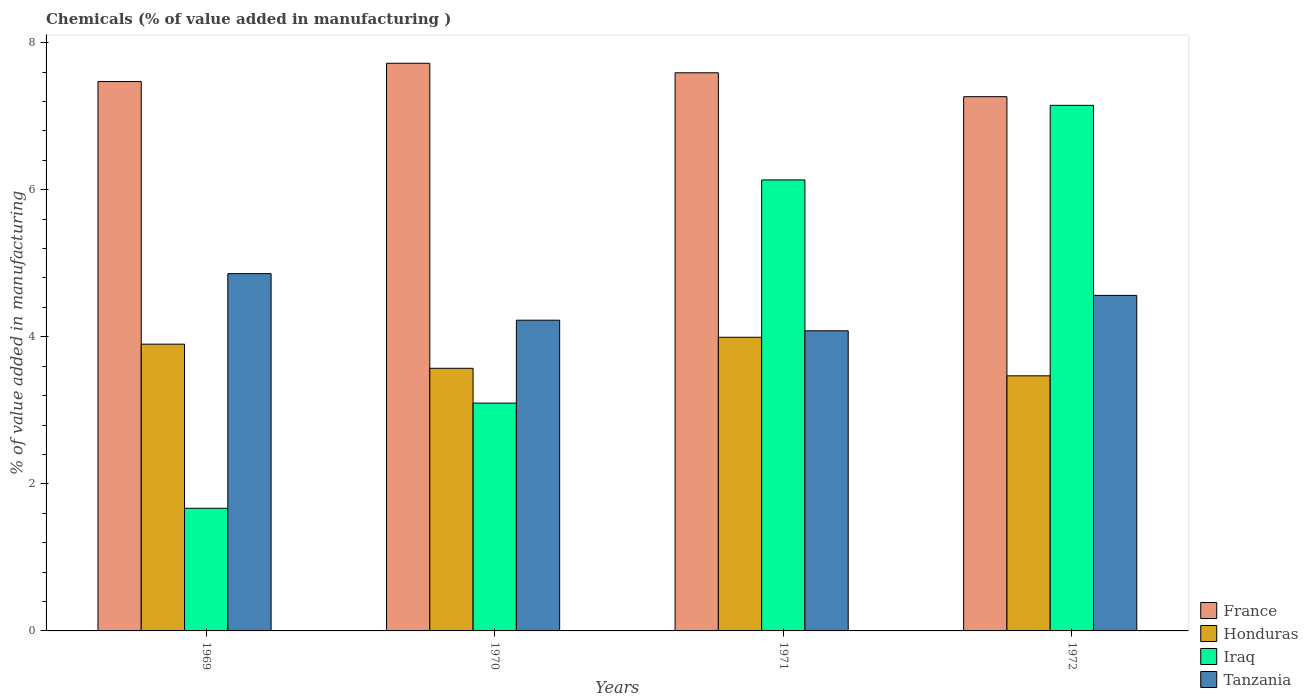How many groups of bars are there?
Your answer should be very brief. 4. Are the number of bars per tick equal to the number of legend labels?
Offer a terse response. Yes. Are the number of bars on each tick of the X-axis equal?
Provide a short and direct response. Yes. In how many cases, is the number of bars for a given year not equal to the number of legend labels?
Ensure brevity in your answer.  0. What is the value added in manufacturing chemicals in Iraq in 1969?
Provide a short and direct response. 1.67. Across all years, what is the maximum value added in manufacturing chemicals in France?
Your response must be concise. 7.72. Across all years, what is the minimum value added in manufacturing chemicals in France?
Your answer should be very brief. 7.26. In which year was the value added in manufacturing chemicals in Iraq minimum?
Provide a succinct answer. 1969. What is the total value added in manufacturing chemicals in Iraq in the graph?
Ensure brevity in your answer.  18.04. What is the difference between the value added in manufacturing chemicals in Honduras in 1969 and that in 1970?
Ensure brevity in your answer.  0.33. What is the difference between the value added in manufacturing chemicals in Honduras in 1970 and the value added in manufacturing chemicals in Tanzania in 1971?
Your answer should be compact. -0.51. What is the average value added in manufacturing chemicals in Honduras per year?
Make the answer very short. 3.73. In the year 1969, what is the difference between the value added in manufacturing chemicals in Honduras and value added in manufacturing chemicals in Tanzania?
Give a very brief answer. -0.96. In how many years, is the value added in manufacturing chemicals in France greater than 3.2 %?
Provide a succinct answer. 4. What is the ratio of the value added in manufacturing chemicals in Tanzania in 1971 to that in 1972?
Your response must be concise. 0.89. Is the value added in manufacturing chemicals in Tanzania in 1970 less than that in 1972?
Ensure brevity in your answer.  Yes. What is the difference between the highest and the second highest value added in manufacturing chemicals in Tanzania?
Provide a succinct answer. 0.3. What is the difference between the highest and the lowest value added in manufacturing chemicals in Iraq?
Provide a short and direct response. 5.48. Is it the case that in every year, the sum of the value added in manufacturing chemicals in Iraq and value added in manufacturing chemicals in France is greater than the sum of value added in manufacturing chemicals in Tanzania and value added in manufacturing chemicals in Honduras?
Give a very brief answer. No. What does the 2nd bar from the left in 1971 represents?
Your response must be concise. Honduras. What does the 1st bar from the right in 1969 represents?
Offer a very short reply. Tanzania. Is it the case that in every year, the sum of the value added in manufacturing chemicals in France and value added in manufacturing chemicals in Iraq is greater than the value added in manufacturing chemicals in Tanzania?
Your answer should be very brief. Yes. Are all the bars in the graph horizontal?
Make the answer very short. No. Are the values on the major ticks of Y-axis written in scientific E-notation?
Your answer should be compact. No. Does the graph contain grids?
Provide a succinct answer. No. Where does the legend appear in the graph?
Your answer should be very brief. Bottom right. How are the legend labels stacked?
Provide a short and direct response. Vertical. What is the title of the graph?
Offer a terse response. Chemicals (% of value added in manufacturing ). What is the label or title of the X-axis?
Your answer should be very brief. Years. What is the label or title of the Y-axis?
Make the answer very short. % of value added in manufacturing. What is the % of value added in manufacturing of France in 1969?
Your answer should be compact. 7.47. What is the % of value added in manufacturing of Honduras in 1969?
Your answer should be compact. 3.9. What is the % of value added in manufacturing in Iraq in 1969?
Your answer should be compact. 1.67. What is the % of value added in manufacturing of Tanzania in 1969?
Your answer should be compact. 4.86. What is the % of value added in manufacturing of France in 1970?
Make the answer very short. 7.72. What is the % of value added in manufacturing of Honduras in 1970?
Offer a very short reply. 3.57. What is the % of value added in manufacturing in Iraq in 1970?
Your answer should be very brief. 3.1. What is the % of value added in manufacturing in Tanzania in 1970?
Keep it short and to the point. 4.23. What is the % of value added in manufacturing of France in 1971?
Keep it short and to the point. 7.59. What is the % of value added in manufacturing in Honduras in 1971?
Offer a terse response. 3.99. What is the % of value added in manufacturing of Iraq in 1971?
Your answer should be compact. 6.13. What is the % of value added in manufacturing of Tanzania in 1971?
Give a very brief answer. 4.08. What is the % of value added in manufacturing of France in 1972?
Offer a terse response. 7.26. What is the % of value added in manufacturing of Honduras in 1972?
Your answer should be compact. 3.47. What is the % of value added in manufacturing of Iraq in 1972?
Your answer should be very brief. 7.15. What is the % of value added in manufacturing in Tanzania in 1972?
Offer a very short reply. 4.56. Across all years, what is the maximum % of value added in manufacturing of France?
Your answer should be compact. 7.72. Across all years, what is the maximum % of value added in manufacturing of Honduras?
Provide a short and direct response. 3.99. Across all years, what is the maximum % of value added in manufacturing of Iraq?
Offer a very short reply. 7.15. Across all years, what is the maximum % of value added in manufacturing in Tanzania?
Provide a short and direct response. 4.86. Across all years, what is the minimum % of value added in manufacturing of France?
Your answer should be compact. 7.26. Across all years, what is the minimum % of value added in manufacturing in Honduras?
Ensure brevity in your answer.  3.47. Across all years, what is the minimum % of value added in manufacturing of Iraq?
Provide a short and direct response. 1.67. Across all years, what is the minimum % of value added in manufacturing of Tanzania?
Offer a terse response. 4.08. What is the total % of value added in manufacturing of France in the graph?
Provide a short and direct response. 30.04. What is the total % of value added in manufacturing in Honduras in the graph?
Your answer should be very brief. 14.93. What is the total % of value added in manufacturing in Iraq in the graph?
Offer a very short reply. 18.04. What is the total % of value added in manufacturing in Tanzania in the graph?
Offer a terse response. 17.73. What is the difference between the % of value added in manufacturing of France in 1969 and that in 1970?
Make the answer very short. -0.25. What is the difference between the % of value added in manufacturing in Honduras in 1969 and that in 1970?
Your response must be concise. 0.33. What is the difference between the % of value added in manufacturing of Iraq in 1969 and that in 1970?
Your response must be concise. -1.43. What is the difference between the % of value added in manufacturing in Tanzania in 1969 and that in 1970?
Your response must be concise. 0.63. What is the difference between the % of value added in manufacturing of France in 1969 and that in 1971?
Give a very brief answer. -0.12. What is the difference between the % of value added in manufacturing of Honduras in 1969 and that in 1971?
Keep it short and to the point. -0.09. What is the difference between the % of value added in manufacturing in Iraq in 1969 and that in 1971?
Ensure brevity in your answer.  -4.46. What is the difference between the % of value added in manufacturing of Tanzania in 1969 and that in 1971?
Make the answer very short. 0.78. What is the difference between the % of value added in manufacturing in France in 1969 and that in 1972?
Ensure brevity in your answer.  0.21. What is the difference between the % of value added in manufacturing of Honduras in 1969 and that in 1972?
Your response must be concise. 0.43. What is the difference between the % of value added in manufacturing in Iraq in 1969 and that in 1972?
Keep it short and to the point. -5.48. What is the difference between the % of value added in manufacturing of Tanzania in 1969 and that in 1972?
Make the answer very short. 0.3. What is the difference between the % of value added in manufacturing of France in 1970 and that in 1971?
Offer a terse response. 0.13. What is the difference between the % of value added in manufacturing in Honduras in 1970 and that in 1971?
Ensure brevity in your answer.  -0.42. What is the difference between the % of value added in manufacturing of Iraq in 1970 and that in 1971?
Provide a succinct answer. -3.03. What is the difference between the % of value added in manufacturing in Tanzania in 1970 and that in 1971?
Provide a succinct answer. 0.14. What is the difference between the % of value added in manufacturing of France in 1970 and that in 1972?
Ensure brevity in your answer.  0.45. What is the difference between the % of value added in manufacturing of Honduras in 1970 and that in 1972?
Your answer should be very brief. 0.1. What is the difference between the % of value added in manufacturing in Iraq in 1970 and that in 1972?
Your response must be concise. -4.05. What is the difference between the % of value added in manufacturing of Tanzania in 1970 and that in 1972?
Make the answer very short. -0.34. What is the difference between the % of value added in manufacturing of France in 1971 and that in 1972?
Give a very brief answer. 0.32. What is the difference between the % of value added in manufacturing in Honduras in 1971 and that in 1972?
Offer a very short reply. 0.52. What is the difference between the % of value added in manufacturing in Iraq in 1971 and that in 1972?
Give a very brief answer. -1.01. What is the difference between the % of value added in manufacturing in Tanzania in 1971 and that in 1972?
Offer a terse response. -0.48. What is the difference between the % of value added in manufacturing in France in 1969 and the % of value added in manufacturing in Honduras in 1970?
Your answer should be very brief. 3.9. What is the difference between the % of value added in manufacturing in France in 1969 and the % of value added in manufacturing in Iraq in 1970?
Ensure brevity in your answer.  4.37. What is the difference between the % of value added in manufacturing in France in 1969 and the % of value added in manufacturing in Tanzania in 1970?
Keep it short and to the point. 3.25. What is the difference between the % of value added in manufacturing in Honduras in 1969 and the % of value added in manufacturing in Iraq in 1970?
Your answer should be compact. 0.8. What is the difference between the % of value added in manufacturing in Honduras in 1969 and the % of value added in manufacturing in Tanzania in 1970?
Make the answer very short. -0.33. What is the difference between the % of value added in manufacturing in Iraq in 1969 and the % of value added in manufacturing in Tanzania in 1970?
Offer a terse response. -2.56. What is the difference between the % of value added in manufacturing of France in 1969 and the % of value added in manufacturing of Honduras in 1971?
Make the answer very short. 3.48. What is the difference between the % of value added in manufacturing in France in 1969 and the % of value added in manufacturing in Iraq in 1971?
Make the answer very short. 1.34. What is the difference between the % of value added in manufacturing in France in 1969 and the % of value added in manufacturing in Tanzania in 1971?
Offer a very short reply. 3.39. What is the difference between the % of value added in manufacturing of Honduras in 1969 and the % of value added in manufacturing of Iraq in 1971?
Offer a terse response. -2.23. What is the difference between the % of value added in manufacturing in Honduras in 1969 and the % of value added in manufacturing in Tanzania in 1971?
Provide a short and direct response. -0.18. What is the difference between the % of value added in manufacturing in Iraq in 1969 and the % of value added in manufacturing in Tanzania in 1971?
Your answer should be very brief. -2.41. What is the difference between the % of value added in manufacturing in France in 1969 and the % of value added in manufacturing in Honduras in 1972?
Your response must be concise. 4. What is the difference between the % of value added in manufacturing in France in 1969 and the % of value added in manufacturing in Iraq in 1972?
Ensure brevity in your answer.  0.32. What is the difference between the % of value added in manufacturing of France in 1969 and the % of value added in manufacturing of Tanzania in 1972?
Keep it short and to the point. 2.91. What is the difference between the % of value added in manufacturing in Honduras in 1969 and the % of value added in manufacturing in Iraq in 1972?
Give a very brief answer. -3.25. What is the difference between the % of value added in manufacturing in Honduras in 1969 and the % of value added in manufacturing in Tanzania in 1972?
Offer a very short reply. -0.66. What is the difference between the % of value added in manufacturing in Iraq in 1969 and the % of value added in manufacturing in Tanzania in 1972?
Ensure brevity in your answer.  -2.89. What is the difference between the % of value added in manufacturing of France in 1970 and the % of value added in manufacturing of Honduras in 1971?
Offer a terse response. 3.73. What is the difference between the % of value added in manufacturing of France in 1970 and the % of value added in manufacturing of Iraq in 1971?
Your answer should be compact. 1.59. What is the difference between the % of value added in manufacturing of France in 1970 and the % of value added in manufacturing of Tanzania in 1971?
Offer a very short reply. 3.64. What is the difference between the % of value added in manufacturing in Honduras in 1970 and the % of value added in manufacturing in Iraq in 1971?
Provide a succinct answer. -2.56. What is the difference between the % of value added in manufacturing in Honduras in 1970 and the % of value added in manufacturing in Tanzania in 1971?
Offer a very short reply. -0.51. What is the difference between the % of value added in manufacturing in Iraq in 1970 and the % of value added in manufacturing in Tanzania in 1971?
Your answer should be compact. -0.98. What is the difference between the % of value added in manufacturing of France in 1970 and the % of value added in manufacturing of Honduras in 1972?
Give a very brief answer. 4.25. What is the difference between the % of value added in manufacturing of France in 1970 and the % of value added in manufacturing of Iraq in 1972?
Give a very brief answer. 0.57. What is the difference between the % of value added in manufacturing of France in 1970 and the % of value added in manufacturing of Tanzania in 1972?
Provide a short and direct response. 3.16. What is the difference between the % of value added in manufacturing in Honduras in 1970 and the % of value added in manufacturing in Iraq in 1972?
Keep it short and to the point. -3.58. What is the difference between the % of value added in manufacturing of Honduras in 1970 and the % of value added in manufacturing of Tanzania in 1972?
Give a very brief answer. -0.99. What is the difference between the % of value added in manufacturing of Iraq in 1970 and the % of value added in manufacturing of Tanzania in 1972?
Offer a very short reply. -1.46. What is the difference between the % of value added in manufacturing in France in 1971 and the % of value added in manufacturing in Honduras in 1972?
Keep it short and to the point. 4.12. What is the difference between the % of value added in manufacturing in France in 1971 and the % of value added in manufacturing in Iraq in 1972?
Offer a very short reply. 0.44. What is the difference between the % of value added in manufacturing in France in 1971 and the % of value added in manufacturing in Tanzania in 1972?
Provide a succinct answer. 3.03. What is the difference between the % of value added in manufacturing of Honduras in 1971 and the % of value added in manufacturing of Iraq in 1972?
Make the answer very short. -3.15. What is the difference between the % of value added in manufacturing in Honduras in 1971 and the % of value added in manufacturing in Tanzania in 1972?
Your answer should be very brief. -0.57. What is the difference between the % of value added in manufacturing in Iraq in 1971 and the % of value added in manufacturing in Tanzania in 1972?
Provide a succinct answer. 1.57. What is the average % of value added in manufacturing of France per year?
Make the answer very short. 7.51. What is the average % of value added in manufacturing in Honduras per year?
Give a very brief answer. 3.73. What is the average % of value added in manufacturing of Iraq per year?
Give a very brief answer. 4.51. What is the average % of value added in manufacturing of Tanzania per year?
Provide a succinct answer. 4.43. In the year 1969, what is the difference between the % of value added in manufacturing of France and % of value added in manufacturing of Honduras?
Offer a very short reply. 3.57. In the year 1969, what is the difference between the % of value added in manufacturing of France and % of value added in manufacturing of Iraq?
Offer a terse response. 5.8. In the year 1969, what is the difference between the % of value added in manufacturing of France and % of value added in manufacturing of Tanzania?
Your response must be concise. 2.61. In the year 1969, what is the difference between the % of value added in manufacturing in Honduras and % of value added in manufacturing in Iraq?
Give a very brief answer. 2.23. In the year 1969, what is the difference between the % of value added in manufacturing of Honduras and % of value added in manufacturing of Tanzania?
Provide a short and direct response. -0.96. In the year 1969, what is the difference between the % of value added in manufacturing of Iraq and % of value added in manufacturing of Tanzania?
Your answer should be very brief. -3.19. In the year 1970, what is the difference between the % of value added in manufacturing in France and % of value added in manufacturing in Honduras?
Your answer should be very brief. 4.15. In the year 1970, what is the difference between the % of value added in manufacturing of France and % of value added in manufacturing of Iraq?
Offer a terse response. 4.62. In the year 1970, what is the difference between the % of value added in manufacturing of France and % of value added in manufacturing of Tanzania?
Provide a short and direct response. 3.49. In the year 1970, what is the difference between the % of value added in manufacturing in Honduras and % of value added in manufacturing in Iraq?
Give a very brief answer. 0.47. In the year 1970, what is the difference between the % of value added in manufacturing in Honduras and % of value added in manufacturing in Tanzania?
Your answer should be very brief. -0.65. In the year 1970, what is the difference between the % of value added in manufacturing in Iraq and % of value added in manufacturing in Tanzania?
Offer a very short reply. -1.13. In the year 1971, what is the difference between the % of value added in manufacturing in France and % of value added in manufacturing in Honduras?
Provide a short and direct response. 3.6. In the year 1971, what is the difference between the % of value added in manufacturing of France and % of value added in manufacturing of Iraq?
Offer a terse response. 1.46. In the year 1971, what is the difference between the % of value added in manufacturing in France and % of value added in manufacturing in Tanzania?
Make the answer very short. 3.51. In the year 1971, what is the difference between the % of value added in manufacturing in Honduras and % of value added in manufacturing in Iraq?
Your answer should be very brief. -2.14. In the year 1971, what is the difference between the % of value added in manufacturing in Honduras and % of value added in manufacturing in Tanzania?
Ensure brevity in your answer.  -0.09. In the year 1971, what is the difference between the % of value added in manufacturing in Iraq and % of value added in manufacturing in Tanzania?
Your response must be concise. 2.05. In the year 1972, what is the difference between the % of value added in manufacturing of France and % of value added in manufacturing of Honduras?
Offer a terse response. 3.8. In the year 1972, what is the difference between the % of value added in manufacturing in France and % of value added in manufacturing in Iraq?
Make the answer very short. 0.12. In the year 1972, what is the difference between the % of value added in manufacturing in France and % of value added in manufacturing in Tanzania?
Offer a terse response. 2.7. In the year 1972, what is the difference between the % of value added in manufacturing in Honduras and % of value added in manufacturing in Iraq?
Give a very brief answer. -3.68. In the year 1972, what is the difference between the % of value added in manufacturing in Honduras and % of value added in manufacturing in Tanzania?
Keep it short and to the point. -1.09. In the year 1972, what is the difference between the % of value added in manufacturing of Iraq and % of value added in manufacturing of Tanzania?
Offer a very short reply. 2.58. What is the ratio of the % of value added in manufacturing in France in 1969 to that in 1970?
Your answer should be compact. 0.97. What is the ratio of the % of value added in manufacturing of Honduras in 1969 to that in 1970?
Provide a short and direct response. 1.09. What is the ratio of the % of value added in manufacturing in Iraq in 1969 to that in 1970?
Ensure brevity in your answer.  0.54. What is the ratio of the % of value added in manufacturing in Tanzania in 1969 to that in 1970?
Make the answer very short. 1.15. What is the ratio of the % of value added in manufacturing of France in 1969 to that in 1971?
Offer a very short reply. 0.98. What is the ratio of the % of value added in manufacturing in Honduras in 1969 to that in 1971?
Offer a terse response. 0.98. What is the ratio of the % of value added in manufacturing of Iraq in 1969 to that in 1971?
Ensure brevity in your answer.  0.27. What is the ratio of the % of value added in manufacturing in Tanzania in 1969 to that in 1971?
Your answer should be compact. 1.19. What is the ratio of the % of value added in manufacturing in France in 1969 to that in 1972?
Keep it short and to the point. 1.03. What is the ratio of the % of value added in manufacturing in Honduras in 1969 to that in 1972?
Ensure brevity in your answer.  1.12. What is the ratio of the % of value added in manufacturing in Iraq in 1969 to that in 1972?
Make the answer very short. 0.23. What is the ratio of the % of value added in manufacturing in Tanzania in 1969 to that in 1972?
Make the answer very short. 1.06. What is the ratio of the % of value added in manufacturing of France in 1970 to that in 1971?
Offer a very short reply. 1.02. What is the ratio of the % of value added in manufacturing in Honduras in 1970 to that in 1971?
Provide a succinct answer. 0.89. What is the ratio of the % of value added in manufacturing of Iraq in 1970 to that in 1971?
Your answer should be very brief. 0.51. What is the ratio of the % of value added in manufacturing of Tanzania in 1970 to that in 1971?
Make the answer very short. 1.04. What is the ratio of the % of value added in manufacturing in France in 1970 to that in 1972?
Your answer should be very brief. 1.06. What is the ratio of the % of value added in manufacturing of Honduras in 1970 to that in 1972?
Your answer should be very brief. 1.03. What is the ratio of the % of value added in manufacturing in Iraq in 1970 to that in 1972?
Make the answer very short. 0.43. What is the ratio of the % of value added in manufacturing in Tanzania in 1970 to that in 1972?
Your answer should be very brief. 0.93. What is the ratio of the % of value added in manufacturing of France in 1971 to that in 1972?
Ensure brevity in your answer.  1.04. What is the ratio of the % of value added in manufacturing of Honduras in 1971 to that in 1972?
Your answer should be very brief. 1.15. What is the ratio of the % of value added in manufacturing of Iraq in 1971 to that in 1972?
Ensure brevity in your answer.  0.86. What is the ratio of the % of value added in manufacturing in Tanzania in 1971 to that in 1972?
Your answer should be very brief. 0.89. What is the difference between the highest and the second highest % of value added in manufacturing of France?
Your answer should be compact. 0.13. What is the difference between the highest and the second highest % of value added in manufacturing of Honduras?
Keep it short and to the point. 0.09. What is the difference between the highest and the second highest % of value added in manufacturing in Iraq?
Your answer should be compact. 1.01. What is the difference between the highest and the second highest % of value added in manufacturing of Tanzania?
Offer a very short reply. 0.3. What is the difference between the highest and the lowest % of value added in manufacturing in France?
Provide a succinct answer. 0.45. What is the difference between the highest and the lowest % of value added in manufacturing in Honduras?
Offer a terse response. 0.52. What is the difference between the highest and the lowest % of value added in manufacturing in Iraq?
Ensure brevity in your answer.  5.48. What is the difference between the highest and the lowest % of value added in manufacturing of Tanzania?
Provide a succinct answer. 0.78. 